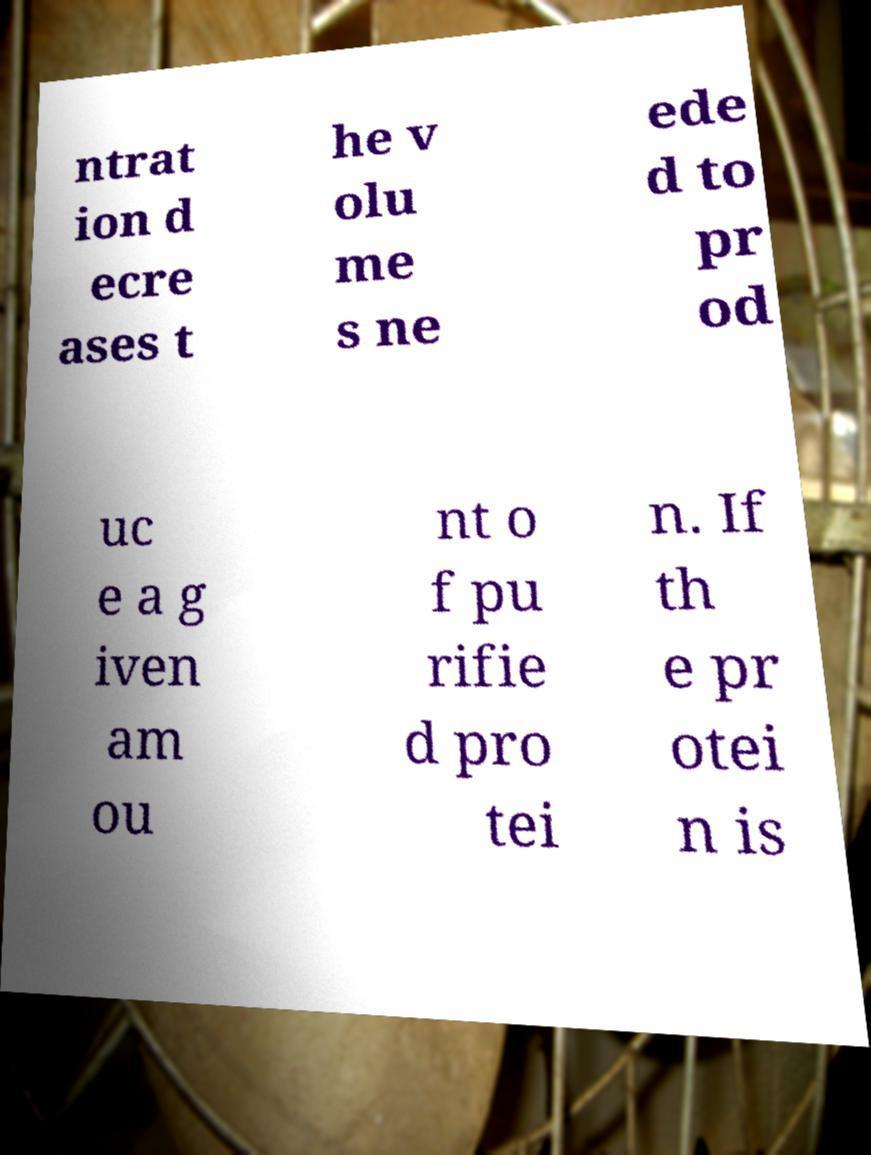What messages or text are displayed in this image? I need them in a readable, typed format. ntrat ion d ecre ases t he v olu me s ne ede d to pr od uc e a g iven am ou nt o f pu rifie d pro tei n. If th e pr otei n is 